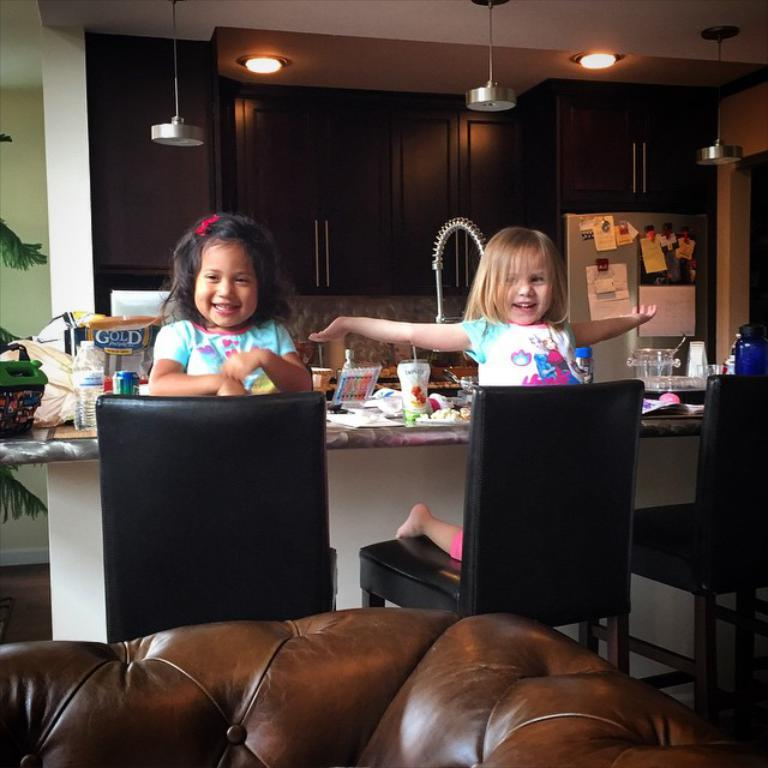How many girls are in the image? There are two girls in the image. What are the girls doing in the image? The girls are sitting on a chair. What other furniture is present in the image? There is a sofa and a table in the image. What can be found on the table? There is a glass, food, and a bottle on the table. What type of lighting is present in the image? There are lights in the image. Is there any storage furniture in the image? Yes, there is a shelf in the image. What type of waves can be seen in the image? There are no waves present in the image. What is the color of the girls' teeth in the image? There is no information about the girls' teeth in the image, so we cannot determine their color. 